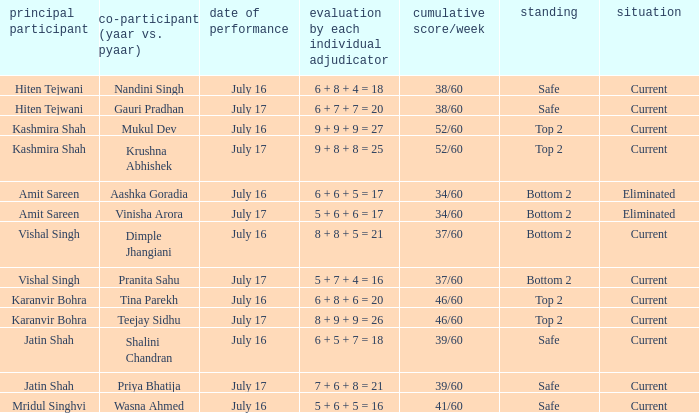Who performed with Tina Parekh? Karanvir Bohra. 